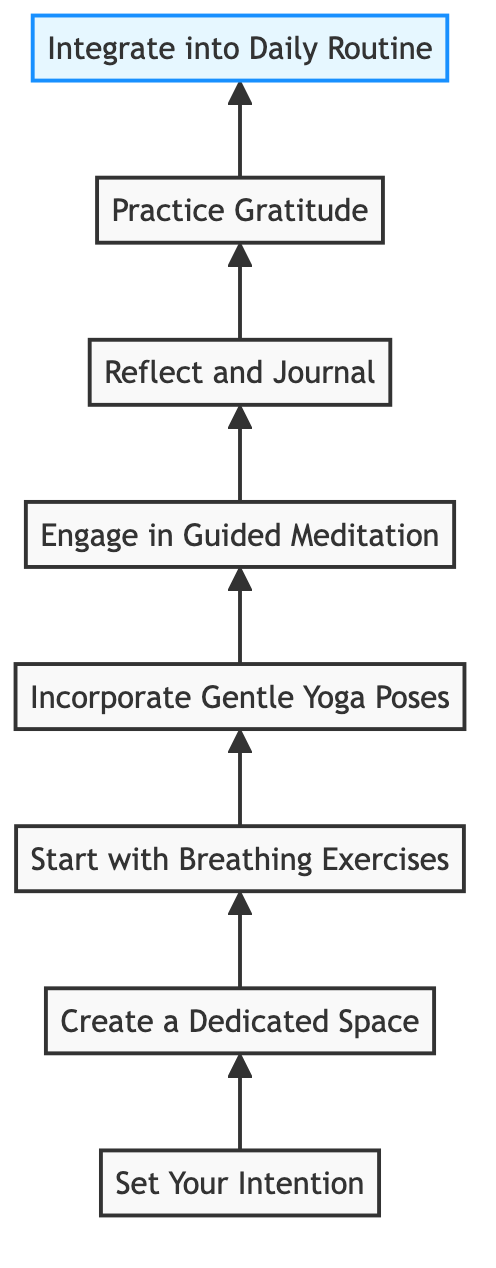What is the first step depicted in the diagram? The first step in the diagram is labeled "Set Your Intention."
Answer: Set Your Intention How many total steps are outlined in the diagram? The diagram outlines a total of eight steps, as indicated by the numbered sequence from A to H.
Answer: 8 What is the last step mentioned in the flow chart? The last step mentioned in the flow chart is "Integrate into Daily Routine."
Answer: Integrate into Daily Routine Which step comes directly after "Start with Breathing Exercises"? "Incorporate Gentle Yoga Poses" is the step that comes directly after "Start with Breathing Exercises," as shown by the arrow connecting C to D.
Answer: Incorporate Gentle Yoga Poses What is the relationship between "Practice Gratitude" and "Reflect and Journal"? "Reflect and Journal" precedes and connects directly to "Practice Gratitude," showing a progression in the sequence of steps.
Answer: Reflect and Journal precedes Practice Gratitude What step follows "Engage in Guided Meditation"? The step that follows "Engage in Guided Meditation" is "Reflect and Journal," which is the next step in the flow after E.
Answer: Reflect and Journal Is "Create a Dedicated Space" the beginning or the end of the flow? "Create a Dedicated Space" is the second step and thus is not at the beginning or the end of the flow, positioning it in the middle of the overall process.
Answer: Middle of the flow How does one achieve mindfulness according to the diagram? Mindfulness can be achieved by engaging in guided meditation, which is specifically indicated as a step in the process outlined in the diagram.
Answer: By engaging in guided meditation Which step concludes the flow? The final step at the top of the flow chart that concludes the sequence is "Integrate into Daily Routine."
Answer: Integrate into Daily Routine 